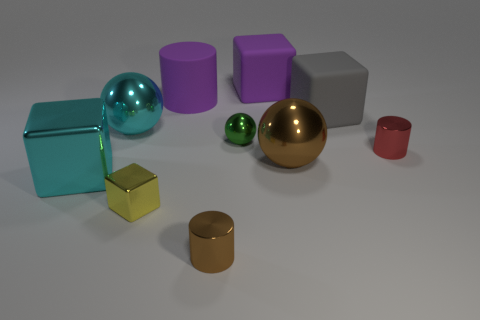Imagine these objects are in a children's playroom. How could they be used for a game? In a children's playroom, these geometric shapes could be used for a sorting and stacking game, where children could group the objects by color or shape, stack them to create towers, or even use them to play a version of hide and seek by finding objects of a particular characteristic. 